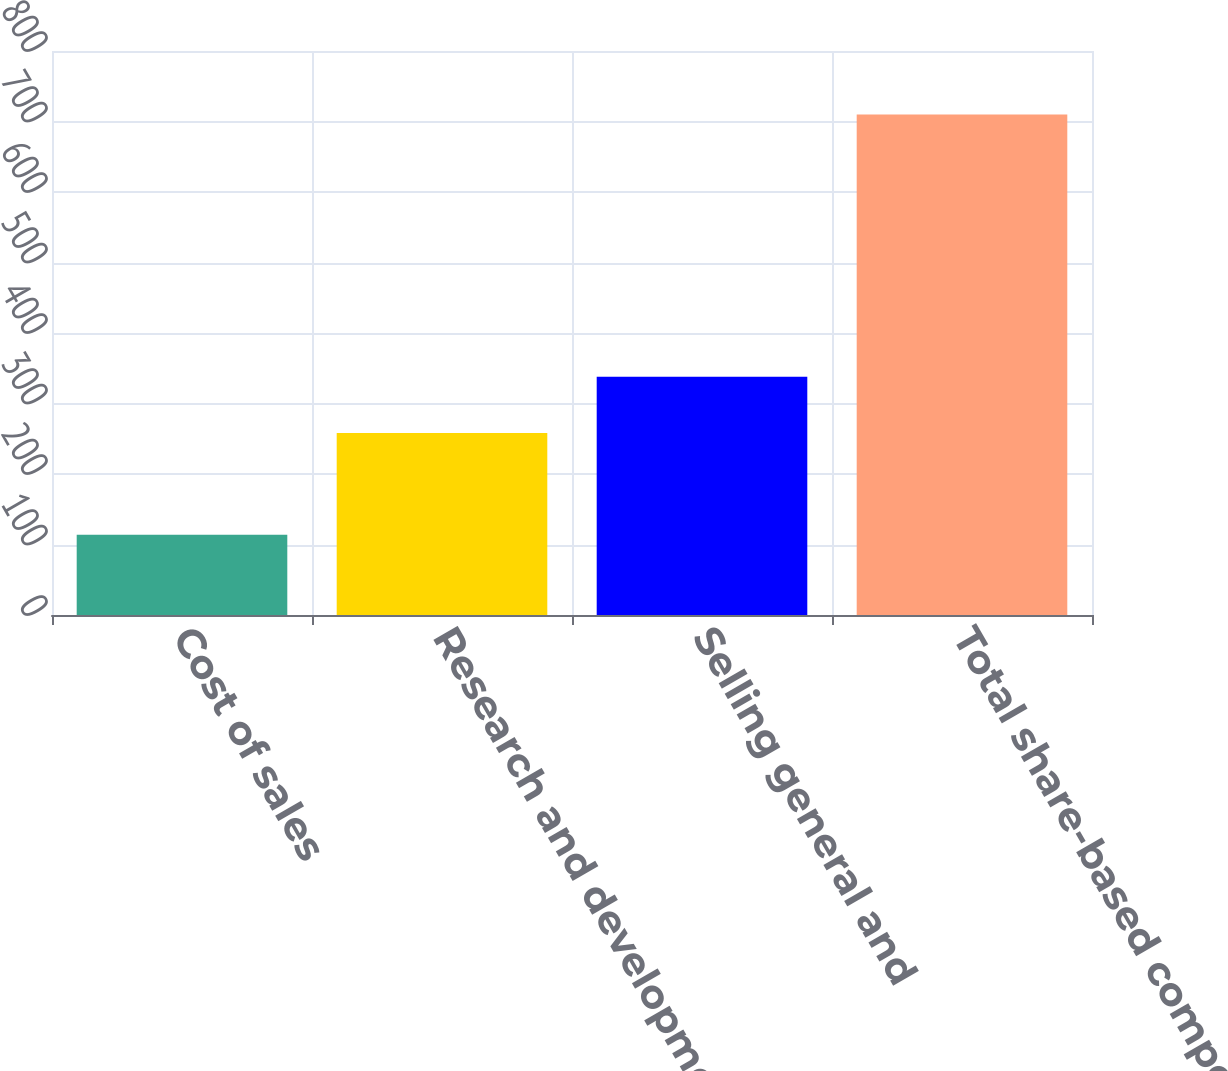Convert chart to OTSL. <chart><loc_0><loc_0><loc_500><loc_500><bar_chart><fcel>Cost of sales<fcel>Research and development<fcel>Selling general and<fcel>Total share-based compensation<nl><fcel>114<fcel>258<fcel>338<fcel>710<nl></chart> 